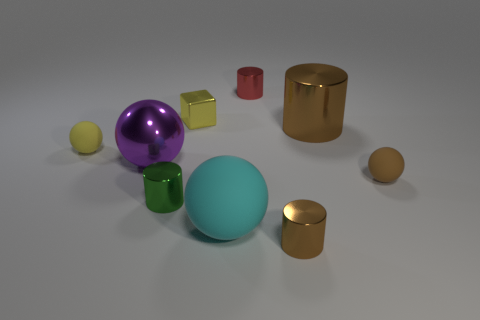How many tiny objects are in front of the big cylinder and behind the purple metal object? 1 